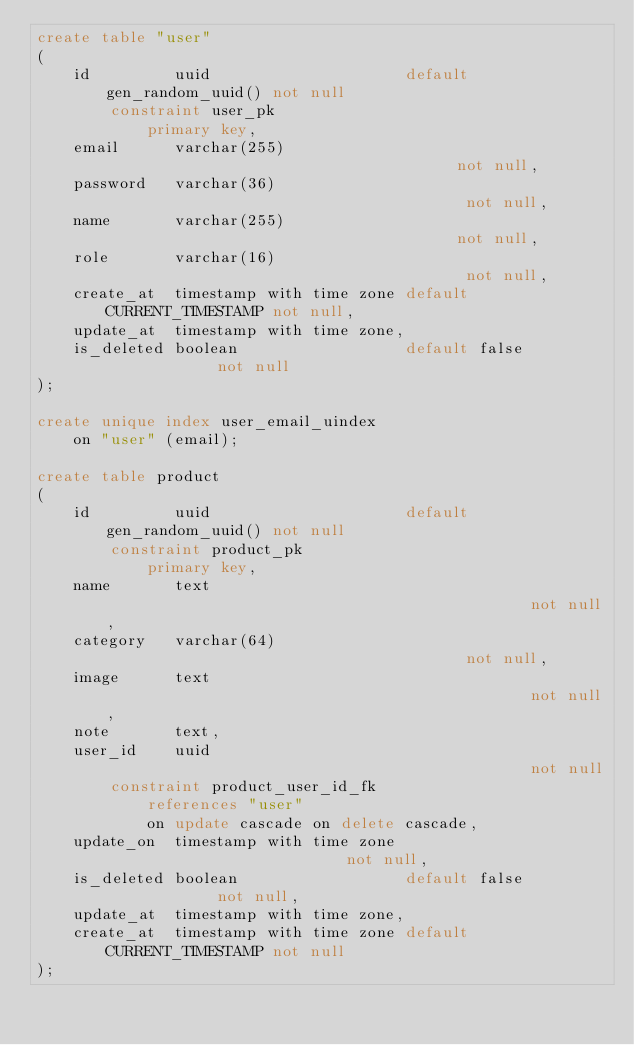<code> <loc_0><loc_0><loc_500><loc_500><_SQL_>create table "user"
(
    id         uuid                     default gen_random_uuid() not null
        constraint user_pk
            primary key,
    email      varchar(255)                                       not null,
    password   varchar(36)                                        not null,
    name       varchar(255)                                       not null,
    role       varchar(16)                                        not null,
    create_at  timestamp with time zone default CURRENT_TIMESTAMP not null,
    update_at  timestamp with time zone,
    is_deleted boolean                  default false             not null
);

create unique index user_email_uindex
    on "user" (email);

create table product
(
    id         uuid                     default gen_random_uuid() not null
        constraint product_pk
            primary key,
    name       text                                               not null,
    category   varchar(64)                                        not null,
    image      text                                               not null,
    note       text,
    user_id    uuid                                               not null
        constraint product_user_id_fk
            references "user"
            on update cascade on delete cascade,
    update_on  timestamp with time zone                           not null,
    is_deleted boolean                  default false             not null,
    update_at  timestamp with time zone,
    create_at  timestamp with time zone default CURRENT_TIMESTAMP not null
);

</code> 